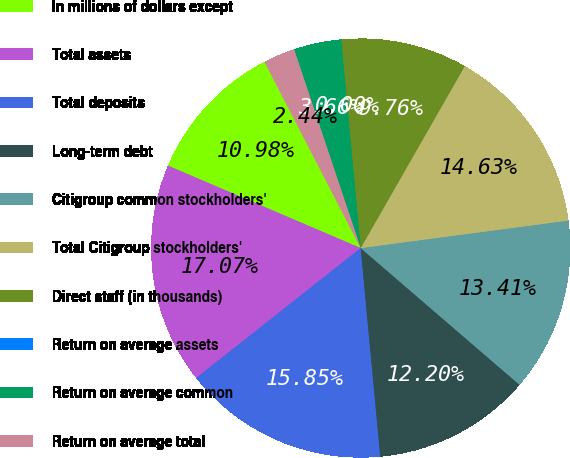<chart> <loc_0><loc_0><loc_500><loc_500><pie_chart><fcel>In millions of dollars except<fcel>Total assets<fcel>Total deposits<fcel>Long-term debt<fcel>Citigroup common stockholders'<fcel>Total Citigroup stockholders'<fcel>Direct staff (in thousands)<fcel>Return on average assets<fcel>Return on average common<fcel>Return on average total<nl><fcel>10.98%<fcel>17.07%<fcel>15.85%<fcel>12.2%<fcel>13.41%<fcel>14.63%<fcel>9.76%<fcel>0.0%<fcel>3.66%<fcel>2.44%<nl></chart> 